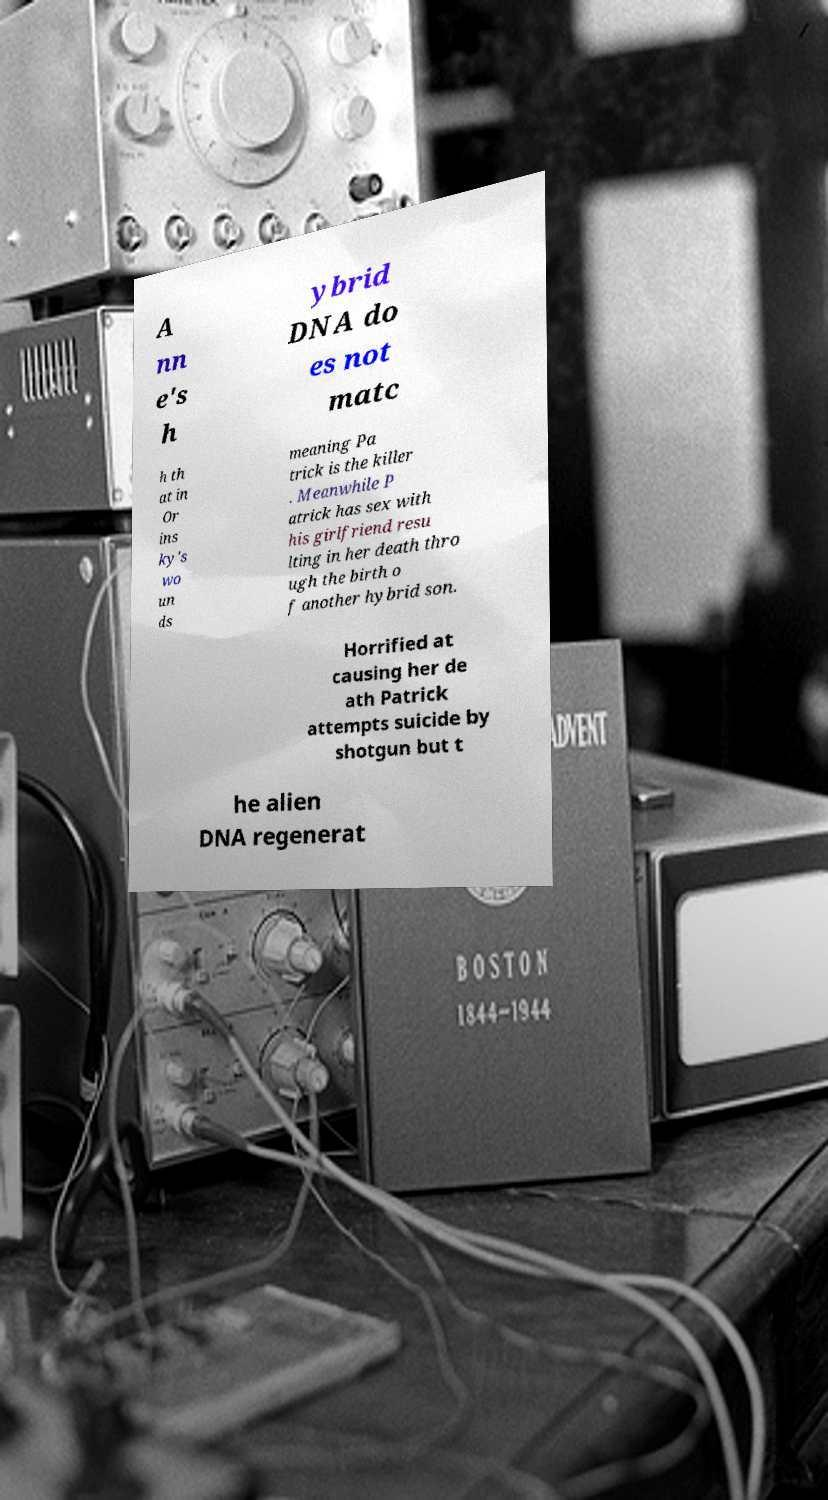Please read and relay the text visible in this image. What does it say? A nn e's h ybrid DNA do es not matc h th at in Or ins ky's wo un ds meaning Pa trick is the killer . Meanwhile P atrick has sex with his girlfriend resu lting in her death thro ugh the birth o f another hybrid son. Horrified at causing her de ath Patrick attempts suicide by shotgun but t he alien DNA regenerat 